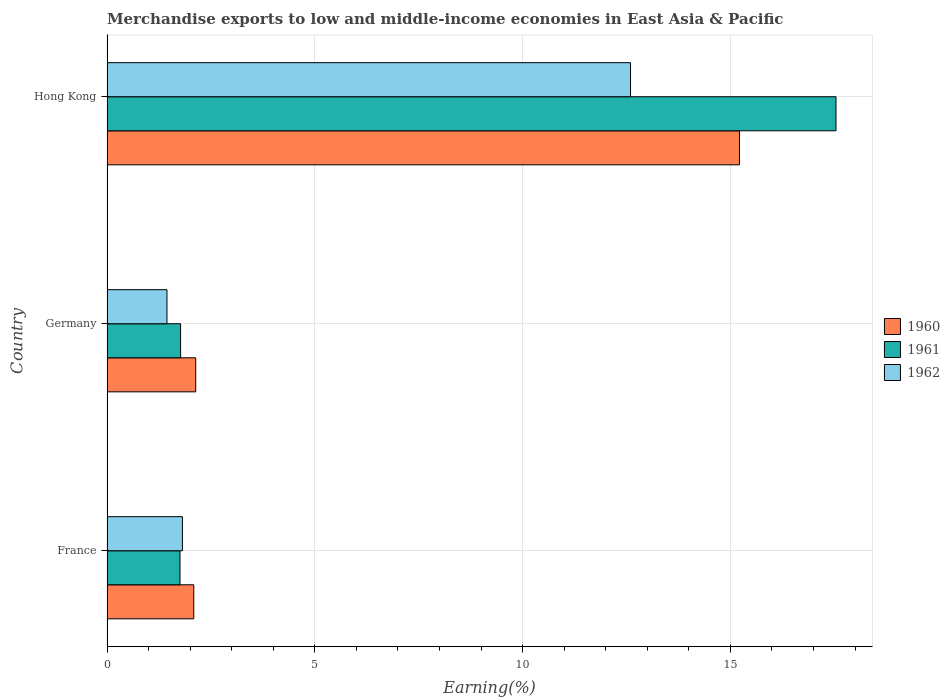How many different coloured bars are there?
Your answer should be compact. 3. How many groups of bars are there?
Make the answer very short. 3. What is the label of the 3rd group of bars from the top?
Make the answer very short. France. In how many cases, is the number of bars for a given country not equal to the number of legend labels?
Keep it short and to the point. 0. What is the percentage of amount earned from merchandise exports in 1961 in Germany?
Your answer should be compact. 1.77. Across all countries, what is the maximum percentage of amount earned from merchandise exports in 1962?
Make the answer very short. 12.6. Across all countries, what is the minimum percentage of amount earned from merchandise exports in 1961?
Ensure brevity in your answer.  1.76. In which country was the percentage of amount earned from merchandise exports in 1960 maximum?
Ensure brevity in your answer.  Hong Kong. What is the total percentage of amount earned from merchandise exports in 1961 in the graph?
Your response must be concise. 21.07. What is the difference between the percentage of amount earned from merchandise exports in 1961 in France and that in Hong Kong?
Keep it short and to the point. -15.79. What is the difference between the percentage of amount earned from merchandise exports in 1962 in Hong Kong and the percentage of amount earned from merchandise exports in 1961 in France?
Ensure brevity in your answer.  10.84. What is the average percentage of amount earned from merchandise exports in 1962 per country?
Ensure brevity in your answer.  5.29. What is the difference between the percentage of amount earned from merchandise exports in 1961 and percentage of amount earned from merchandise exports in 1960 in Germany?
Your response must be concise. -0.36. In how many countries, is the percentage of amount earned from merchandise exports in 1960 greater than 2 %?
Provide a succinct answer. 3. What is the ratio of the percentage of amount earned from merchandise exports in 1960 in France to that in Hong Kong?
Offer a very short reply. 0.14. Is the percentage of amount earned from merchandise exports in 1960 in Germany less than that in Hong Kong?
Keep it short and to the point. Yes. Is the difference between the percentage of amount earned from merchandise exports in 1961 in France and Hong Kong greater than the difference between the percentage of amount earned from merchandise exports in 1960 in France and Hong Kong?
Keep it short and to the point. No. What is the difference between the highest and the second highest percentage of amount earned from merchandise exports in 1960?
Your answer should be very brief. 13.08. What is the difference between the highest and the lowest percentage of amount earned from merchandise exports in 1961?
Keep it short and to the point. 15.79. What does the 2nd bar from the bottom in Hong Kong represents?
Your answer should be very brief. 1961. Is it the case that in every country, the sum of the percentage of amount earned from merchandise exports in 1961 and percentage of amount earned from merchandise exports in 1960 is greater than the percentage of amount earned from merchandise exports in 1962?
Your answer should be compact. Yes. How many bars are there?
Keep it short and to the point. 9. How many countries are there in the graph?
Your answer should be very brief. 3. Are the values on the major ticks of X-axis written in scientific E-notation?
Ensure brevity in your answer.  No. Does the graph contain grids?
Your answer should be very brief. Yes. How many legend labels are there?
Offer a terse response. 3. How are the legend labels stacked?
Keep it short and to the point. Vertical. What is the title of the graph?
Keep it short and to the point. Merchandise exports to low and middle-income economies in East Asia & Pacific. Does "1967" appear as one of the legend labels in the graph?
Offer a very short reply. No. What is the label or title of the X-axis?
Your answer should be very brief. Earning(%). What is the label or title of the Y-axis?
Provide a succinct answer. Country. What is the Earning(%) of 1960 in France?
Provide a short and direct response. 2.09. What is the Earning(%) in 1961 in France?
Make the answer very short. 1.76. What is the Earning(%) of 1962 in France?
Your answer should be very brief. 1.81. What is the Earning(%) of 1960 in Germany?
Ensure brevity in your answer.  2.14. What is the Earning(%) in 1961 in Germany?
Offer a very short reply. 1.77. What is the Earning(%) in 1962 in Germany?
Make the answer very short. 1.44. What is the Earning(%) of 1960 in Hong Kong?
Your answer should be compact. 15.22. What is the Earning(%) of 1961 in Hong Kong?
Give a very brief answer. 17.54. What is the Earning(%) in 1962 in Hong Kong?
Keep it short and to the point. 12.6. Across all countries, what is the maximum Earning(%) of 1960?
Make the answer very short. 15.22. Across all countries, what is the maximum Earning(%) in 1961?
Make the answer very short. 17.54. Across all countries, what is the maximum Earning(%) in 1962?
Make the answer very short. 12.6. Across all countries, what is the minimum Earning(%) of 1960?
Give a very brief answer. 2.09. Across all countries, what is the minimum Earning(%) in 1961?
Keep it short and to the point. 1.76. Across all countries, what is the minimum Earning(%) of 1962?
Your response must be concise. 1.44. What is the total Earning(%) in 1960 in the graph?
Provide a succinct answer. 19.44. What is the total Earning(%) of 1961 in the graph?
Your response must be concise. 21.07. What is the total Earning(%) in 1962 in the graph?
Provide a short and direct response. 15.86. What is the difference between the Earning(%) of 1960 in France and that in Germany?
Your response must be concise. -0.05. What is the difference between the Earning(%) in 1961 in France and that in Germany?
Offer a very short reply. -0.01. What is the difference between the Earning(%) of 1962 in France and that in Germany?
Your response must be concise. 0.37. What is the difference between the Earning(%) of 1960 in France and that in Hong Kong?
Provide a succinct answer. -13.13. What is the difference between the Earning(%) of 1961 in France and that in Hong Kong?
Offer a very short reply. -15.79. What is the difference between the Earning(%) of 1962 in France and that in Hong Kong?
Your answer should be very brief. -10.78. What is the difference between the Earning(%) in 1960 in Germany and that in Hong Kong?
Offer a terse response. -13.08. What is the difference between the Earning(%) of 1961 in Germany and that in Hong Kong?
Provide a succinct answer. -15.77. What is the difference between the Earning(%) of 1962 in Germany and that in Hong Kong?
Your answer should be compact. -11.16. What is the difference between the Earning(%) in 1960 in France and the Earning(%) in 1961 in Germany?
Your answer should be compact. 0.32. What is the difference between the Earning(%) in 1960 in France and the Earning(%) in 1962 in Germany?
Keep it short and to the point. 0.65. What is the difference between the Earning(%) of 1961 in France and the Earning(%) of 1962 in Germany?
Keep it short and to the point. 0.31. What is the difference between the Earning(%) in 1960 in France and the Earning(%) in 1961 in Hong Kong?
Your answer should be very brief. -15.45. What is the difference between the Earning(%) of 1960 in France and the Earning(%) of 1962 in Hong Kong?
Offer a very short reply. -10.51. What is the difference between the Earning(%) in 1961 in France and the Earning(%) in 1962 in Hong Kong?
Make the answer very short. -10.84. What is the difference between the Earning(%) of 1960 in Germany and the Earning(%) of 1961 in Hong Kong?
Keep it short and to the point. -15.41. What is the difference between the Earning(%) of 1960 in Germany and the Earning(%) of 1962 in Hong Kong?
Your response must be concise. -10.46. What is the difference between the Earning(%) of 1961 in Germany and the Earning(%) of 1962 in Hong Kong?
Your response must be concise. -10.83. What is the average Earning(%) of 1960 per country?
Make the answer very short. 6.48. What is the average Earning(%) of 1961 per country?
Provide a succinct answer. 7.02. What is the average Earning(%) of 1962 per country?
Ensure brevity in your answer.  5.29. What is the difference between the Earning(%) of 1960 and Earning(%) of 1961 in France?
Keep it short and to the point. 0.33. What is the difference between the Earning(%) in 1960 and Earning(%) in 1962 in France?
Offer a very short reply. 0.27. What is the difference between the Earning(%) of 1961 and Earning(%) of 1962 in France?
Offer a terse response. -0.06. What is the difference between the Earning(%) of 1960 and Earning(%) of 1961 in Germany?
Your answer should be compact. 0.36. What is the difference between the Earning(%) of 1960 and Earning(%) of 1962 in Germany?
Keep it short and to the point. 0.69. What is the difference between the Earning(%) in 1961 and Earning(%) in 1962 in Germany?
Make the answer very short. 0.33. What is the difference between the Earning(%) in 1960 and Earning(%) in 1961 in Hong Kong?
Offer a terse response. -2.32. What is the difference between the Earning(%) in 1960 and Earning(%) in 1962 in Hong Kong?
Your response must be concise. 2.62. What is the difference between the Earning(%) of 1961 and Earning(%) of 1962 in Hong Kong?
Give a very brief answer. 4.94. What is the ratio of the Earning(%) of 1960 in France to that in Germany?
Your answer should be very brief. 0.98. What is the ratio of the Earning(%) in 1962 in France to that in Germany?
Provide a succinct answer. 1.26. What is the ratio of the Earning(%) in 1960 in France to that in Hong Kong?
Ensure brevity in your answer.  0.14. What is the ratio of the Earning(%) in 1961 in France to that in Hong Kong?
Make the answer very short. 0.1. What is the ratio of the Earning(%) in 1962 in France to that in Hong Kong?
Give a very brief answer. 0.14. What is the ratio of the Earning(%) of 1960 in Germany to that in Hong Kong?
Ensure brevity in your answer.  0.14. What is the ratio of the Earning(%) of 1961 in Germany to that in Hong Kong?
Ensure brevity in your answer.  0.1. What is the ratio of the Earning(%) in 1962 in Germany to that in Hong Kong?
Keep it short and to the point. 0.11. What is the difference between the highest and the second highest Earning(%) in 1960?
Keep it short and to the point. 13.08. What is the difference between the highest and the second highest Earning(%) in 1961?
Keep it short and to the point. 15.77. What is the difference between the highest and the second highest Earning(%) in 1962?
Provide a succinct answer. 10.78. What is the difference between the highest and the lowest Earning(%) of 1960?
Your response must be concise. 13.13. What is the difference between the highest and the lowest Earning(%) in 1961?
Ensure brevity in your answer.  15.79. What is the difference between the highest and the lowest Earning(%) of 1962?
Provide a succinct answer. 11.16. 